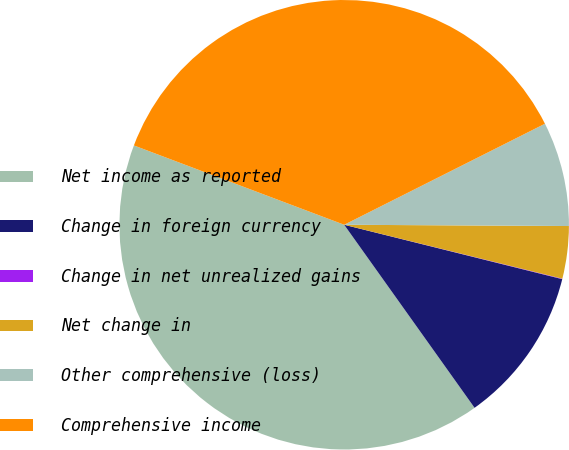<chart> <loc_0><loc_0><loc_500><loc_500><pie_chart><fcel>Net income as reported<fcel>Change in foreign currency<fcel>Change in net unrealized gains<fcel>Net change in<fcel>Other comprehensive (loss)<fcel>Comprehensive income<nl><fcel>40.59%<fcel>11.26%<fcel>0.03%<fcel>3.77%<fcel>7.51%<fcel>36.84%<nl></chart> 